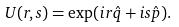<formula> <loc_0><loc_0><loc_500><loc_500>U ( r , s ) = \exp ( i r \hat { q } + i s \hat { p } ) .</formula> 